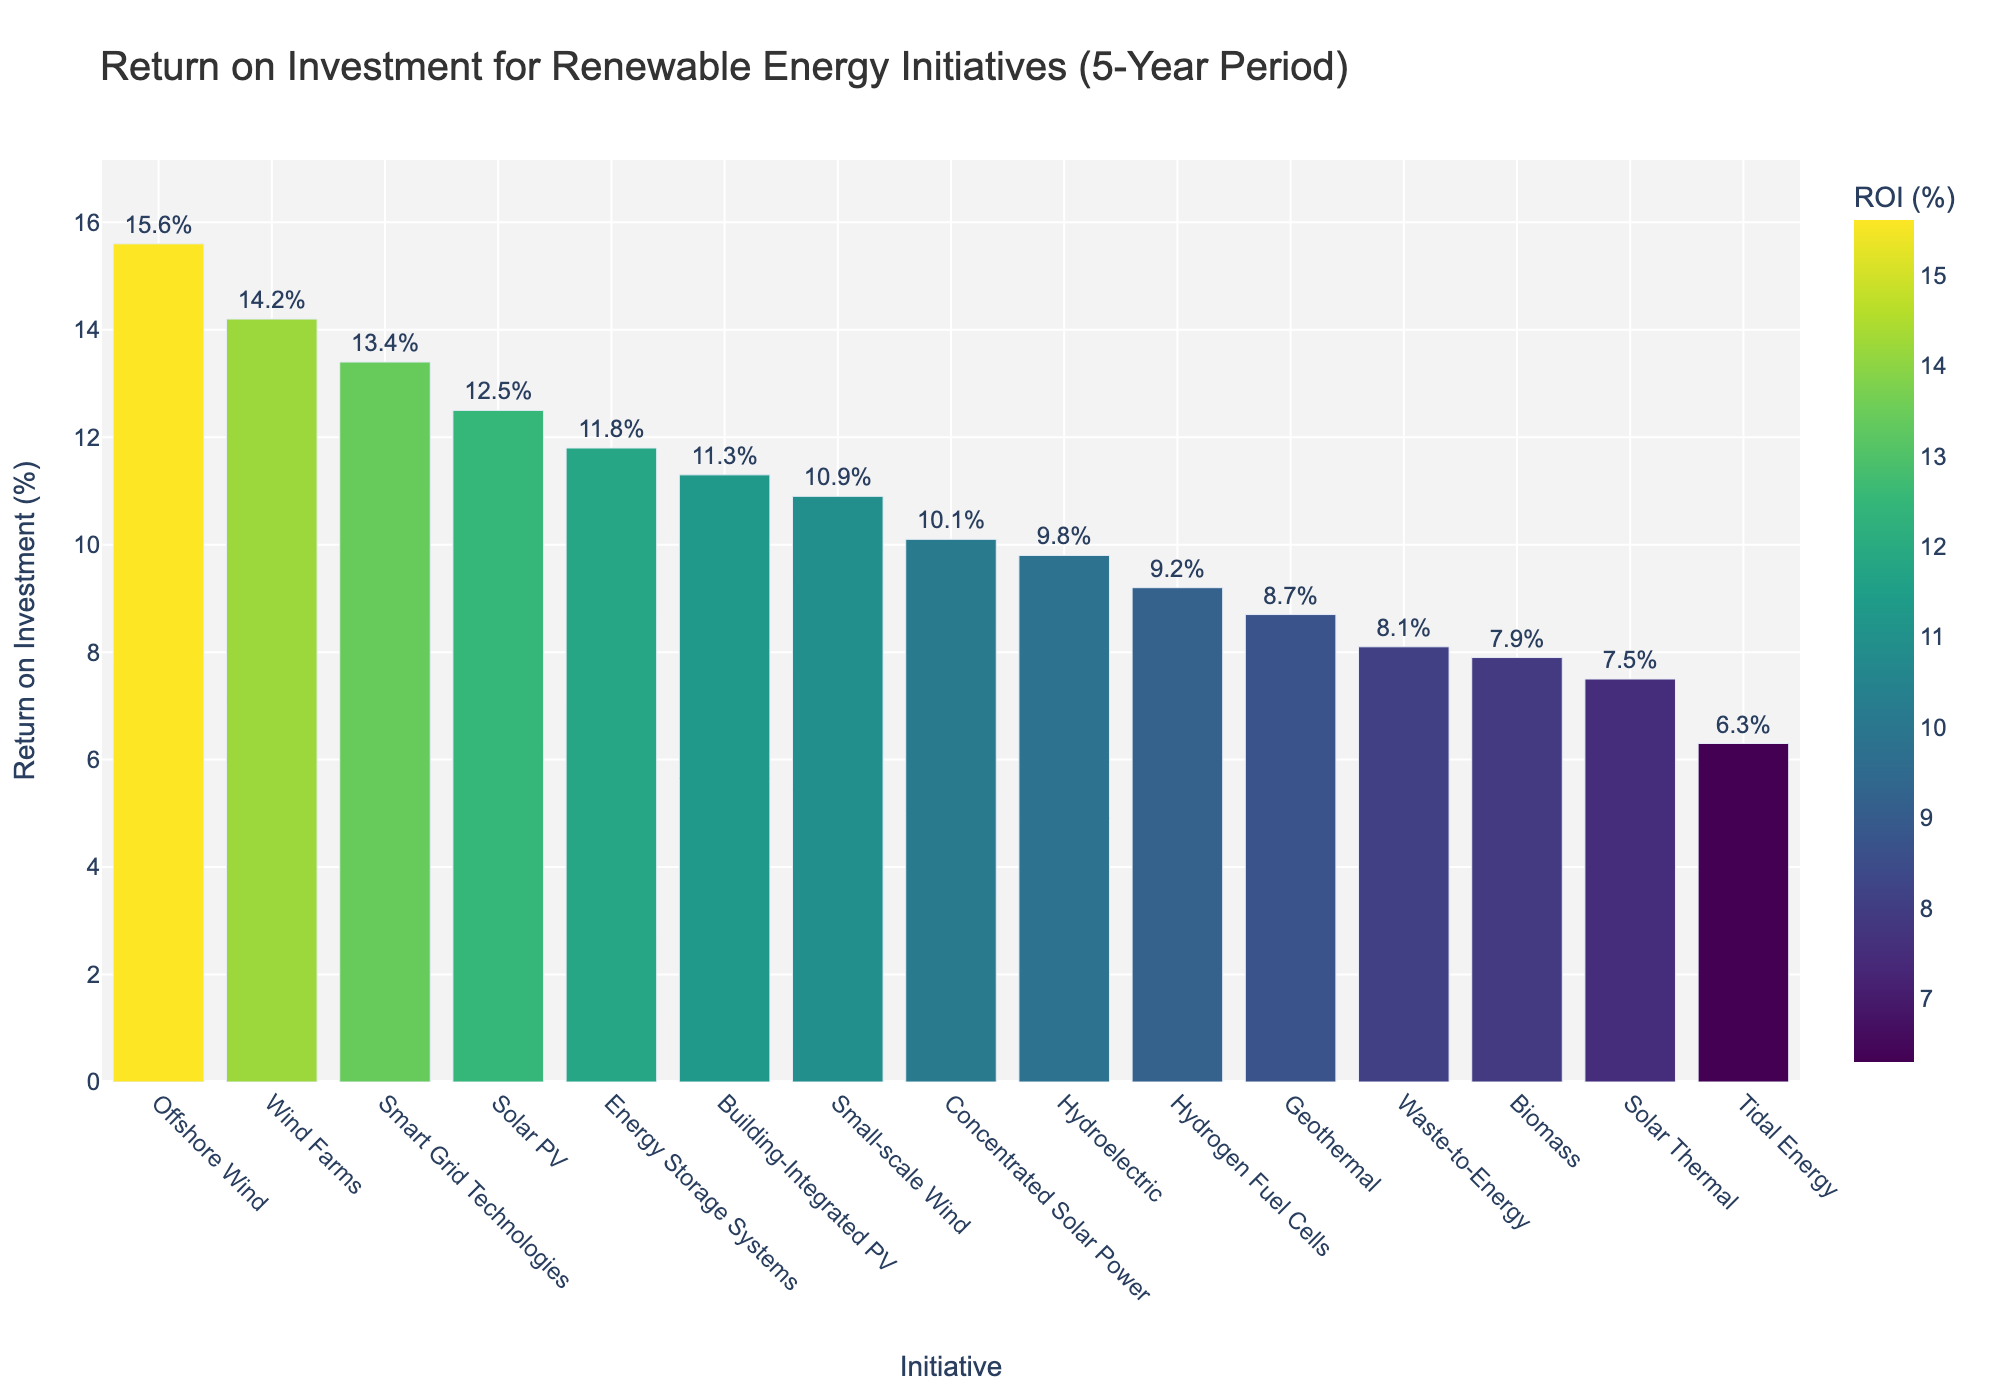Which initiative has the highest ROI? The bar chart visually indicates the heights of the bars, making it evident which is the tallest. The tallest bar represents Offshore Wind.
Answer: Offshore Wind Which two initiatives have the smallest difference in ROI? By examining the heights of the bars that are closest in value, we see that Smart Grid Technologies and Solar PV have similar heights with ROIs of 13.4% and 12.5% respectively.
Answer: Smart Grid Technologies and Solar PV How much greater is the ROI of Wind Farms compared to Biomass? The ROI of Wind Farms is 14.2% and Biomass is 7.9%. The difference is calculated as 14.2 - 7.9 = 6.3%.
Answer: 6.3% Which initiative ranks third by ROI? The sorted bar chart allows us to see the third tallest bar from the left, which corresponds to Solar PV with an ROI of 12.5%.
Answer: Solar PV What is the average ROI of the initiatives with an ROI above 10%? Identify the initiatives: Solar PV (12.5%), Wind Farms (14.2%), Concentrated Solar Power (10.1%), Offshore Wind (15.6%), Energy Storage Systems (11.8%), Smart Grid Technologies (13.4%), Small-scale Wind (10.9%), Building-Integrated PV (11.3%). Then, calculate the average: (12.5 + 14.2 + 10.1 + 15.6 + 11.8 + 13.4 + 10.9 + 11.3)/8 = 12.35%.
Answer: 12.35% What is the median ROI among all initiatives? The ROIs sorted are: 6.3, 7.5, 7.9, 8.1, 8.7, 9.2, 9.8, 10.1, 10.9, 11.3, 11.8, 12.5, 13.4, 14.2, 15.6. With 15 initiatives, the median is the 8th value: 10.1.
Answer: 10.1% Which initiatives fall below the average ROI of all initiatives? The average ROI is the sum of all ROIs divided by the number of initiatives: (12.5 + 14.2 + 9.8 + 8.7 + 7.9 + 6.3 + 10.1 + 15.6 + 11.8 + 13.4 + 9.2 + 8.1 + 7.5 + 10.9 + 11.3)/15 = 10.6%. Initiatives below 10.6% are: Hydroelectric, Geothermal, Biomass, Tidal Energy, Hydrogen Fuel Cells, Waste-to-Energy, and Solar Thermal.
Answer: Hydroelectric, Geothermal, Biomass, Tidal Energy, Hydrogen Fuel Cells, Waste-to-Energy, Solar Thermal 